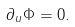Convert formula to latex. <formula><loc_0><loc_0><loc_500><loc_500>\partial _ { u } \Phi = 0 .</formula> 